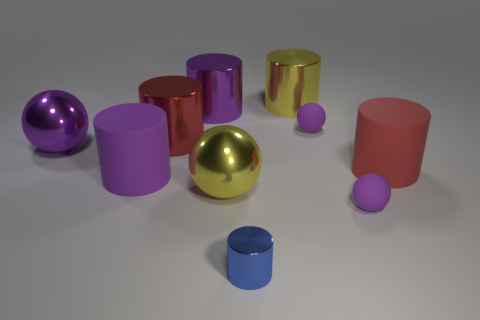Subtract all gray cylinders. How many purple balls are left? 3 Subtract 3 cylinders. How many cylinders are left? 3 Subtract all purple cylinders. How many cylinders are left? 4 Subtract all large yellow cylinders. How many cylinders are left? 5 Subtract all green cylinders. Subtract all red spheres. How many cylinders are left? 6 Subtract all spheres. How many objects are left? 6 Subtract all large things. Subtract all matte cylinders. How many objects are left? 1 Add 2 tiny purple matte things. How many tiny purple matte things are left? 4 Add 6 small metal objects. How many small metal objects exist? 7 Subtract 1 blue cylinders. How many objects are left? 9 